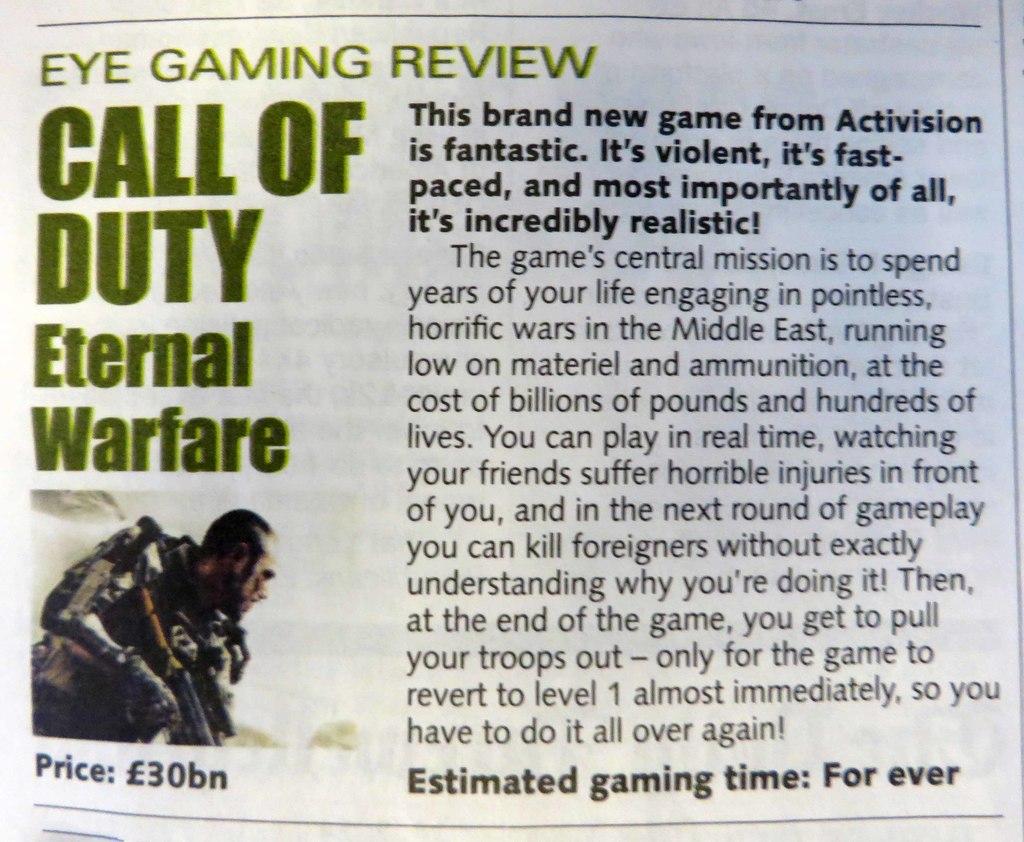What game is being reviewed?
Ensure brevity in your answer.  Call of duty eternal warfare. What is the estimated gaming time?
Give a very brief answer. For ever. 